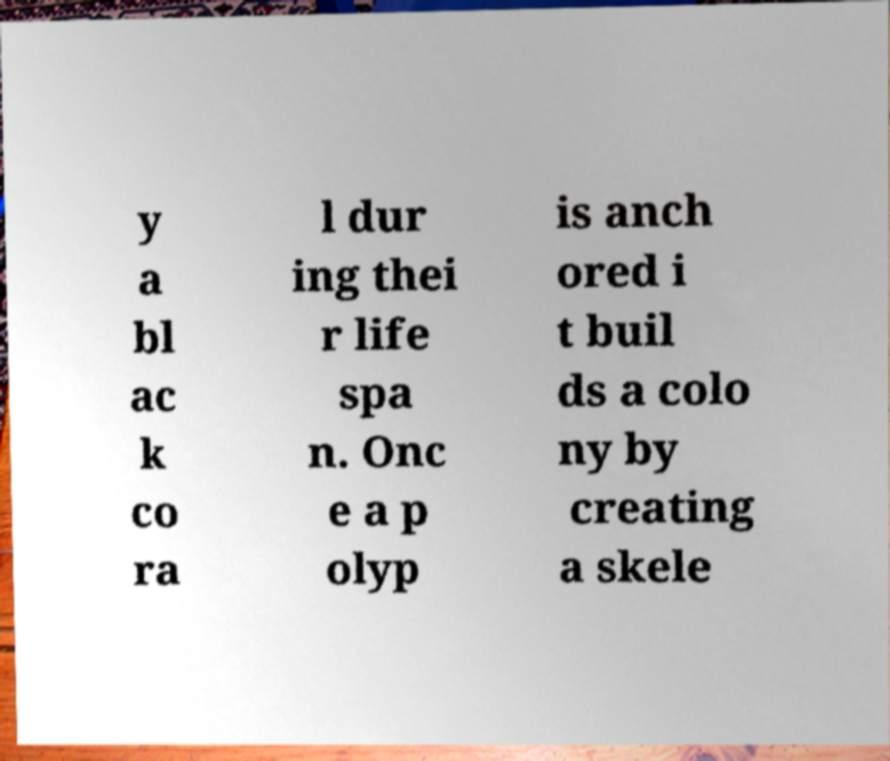For documentation purposes, I need the text within this image transcribed. Could you provide that? y a bl ac k co ra l dur ing thei r life spa n. Onc e a p olyp is anch ored i t buil ds a colo ny by creating a skele 